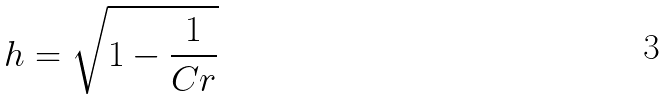Convert formula to latex. <formula><loc_0><loc_0><loc_500><loc_500>h = \sqrt { 1 - \frac { 1 } { C r } }</formula> 